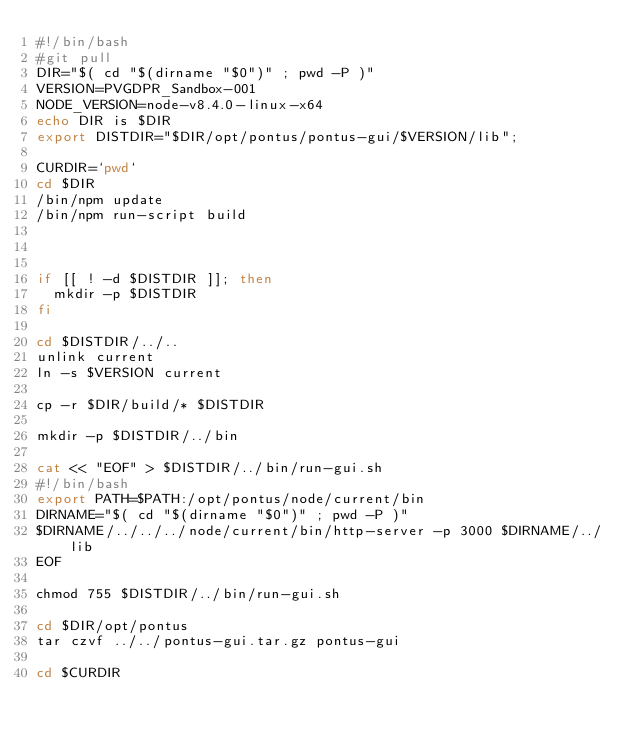Convert code to text. <code><loc_0><loc_0><loc_500><loc_500><_Bash_>#!/bin/bash
#git pull
DIR="$( cd "$(dirname "$0")" ; pwd -P )"
VERSION=PVGDPR_Sandbox-001
NODE_VERSION=node-v8.4.0-linux-x64
echo DIR is $DIR
export DISTDIR="$DIR/opt/pontus/pontus-gui/$VERSION/lib";

CURDIR=`pwd`
cd $DIR
/bin/npm update
/bin/npm run-script build



if [[ ! -d $DISTDIR ]]; then
  mkdir -p $DISTDIR
fi

cd $DISTDIR/../..
unlink current
ln -s $VERSION current

cp -r $DIR/build/* $DISTDIR 

mkdir -p $DISTDIR/../bin

cat << "EOF" > $DISTDIR/../bin/run-gui.sh
#!/bin/bash
export PATH=$PATH:/opt/pontus/node/current/bin
DIRNAME="$( cd "$(dirname "$0")" ; pwd -P )"
$DIRNAME/../../../node/current/bin/http-server -p 3000 $DIRNAME/../lib
EOF

chmod 755 $DISTDIR/../bin/run-gui.sh

cd $DIR/opt/pontus
tar czvf ../../pontus-gui.tar.gz pontus-gui

cd $CURDIR
</code> 